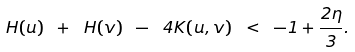<formula> <loc_0><loc_0><loc_500><loc_500>\ H ( u ) \ + \ H ( v ) \ - \ 4 K ( u , v ) \ < \ - 1 + \frac { 2 \eta } { 3 } .</formula> 